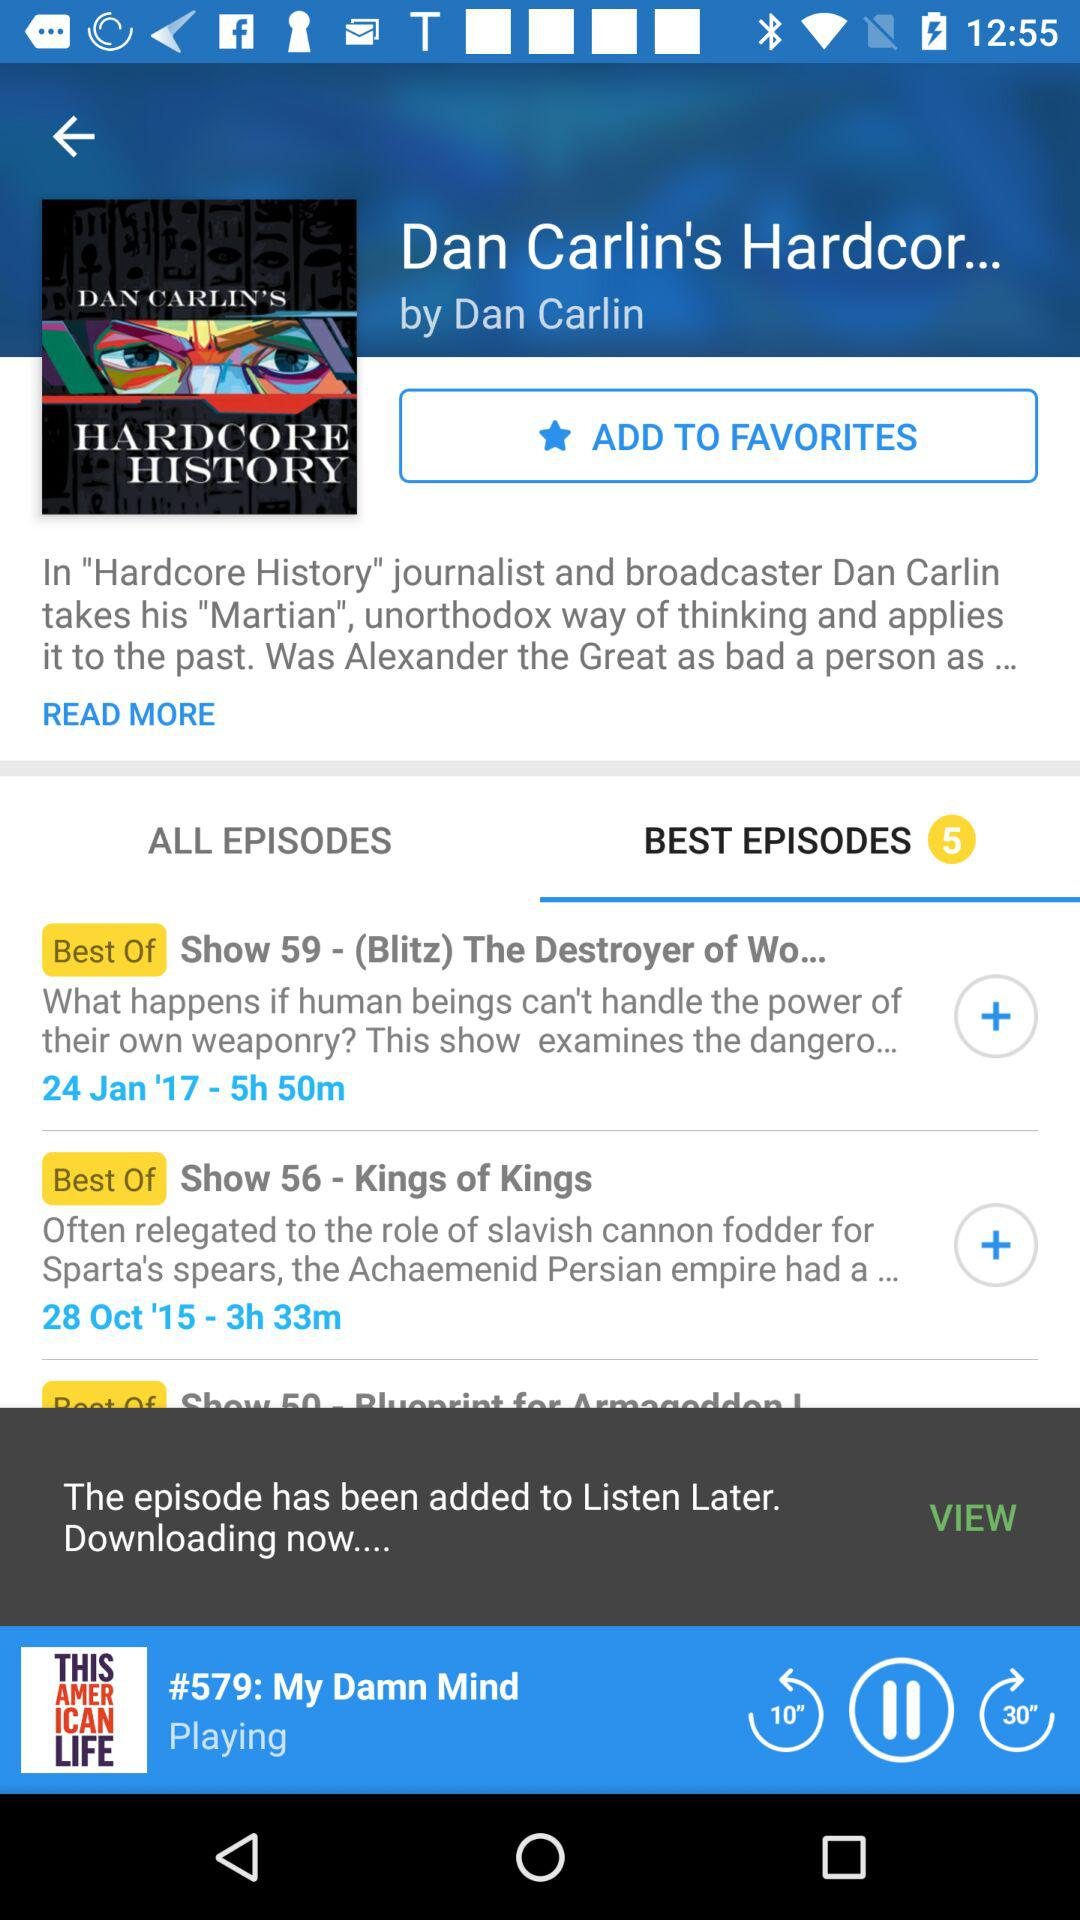What is the duration of "Show 56 - Kings of Kings"? The duration of "Show 56 - Kings of Kings" is 3 hours 33 minutes. 